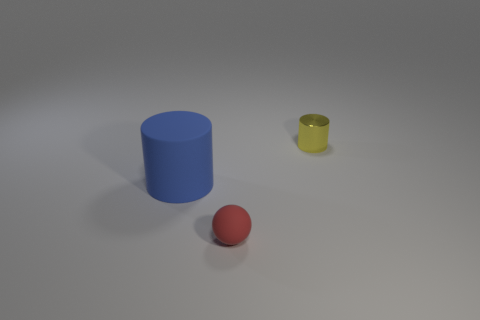Are there any other things that are the same size as the blue cylinder?
Your answer should be very brief. No. Is the size of the cylinder that is in front of the small metal cylinder the same as the rubber object that is in front of the big blue matte object?
Give a very brief answer. No. What shape is the small thing that is in front of the tiny yellow cylinder?
Keep it short and to the point. Sphere. There is another thing that is the same shape as the big blue thing; what is it made of?
Your response must be concise. Metal. Does the cylinder that is in front of the yellow metallic cylinder have the same size as the yellow shiny object?
Your answer should be compact. No. There is a large matte thing; how many small red rubber objects are in front of it?
Your answer should be very brief. 1. Are there fewer tiny metallic things that are on the right side of the small yellow metallic cylinder than big cylinders that are in front of the blue cylinder?
Your answer should be compact. No. What number of yellow cylinders are there?
Provide a succinct answer. 1. There is a object that is on the right side of the tiny red object; what color is it?
Offer a very short reply. Yellow. The red ball has what size?
Offer a terse response. Small. 